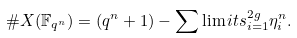<formula> <loc_0><loc_0><loc_500><loc_500>\# X ( \mathbb { F } _ { q ^ { n } } ) = ( q ^ { n } + 1 ) - \sum \lim i t s _ { i = 1 } ^ { 2 g } \eta _ { i } ^ { n } .</formula> 